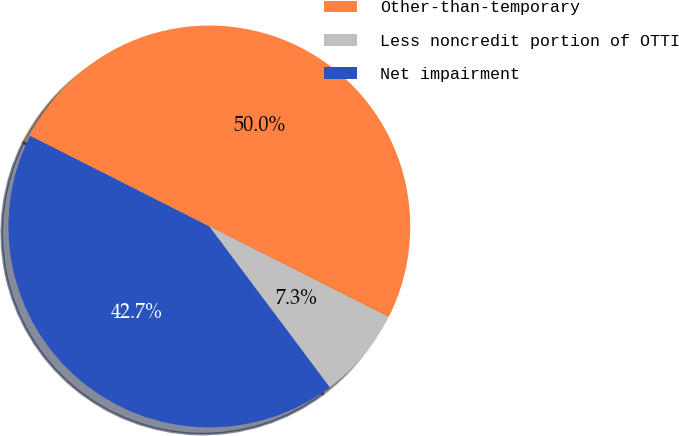Convert chart to OTSL. <chart><loc_0><loc_0><loc_500><loc_500><pie_chart><fcel>Other-than-temporary<fcel>Less noncredit portion of OTTI<fcel>Net impairment<nl><fcel>50.0%<fcel>7.32%<fcel>42.68%<nl></chart> 